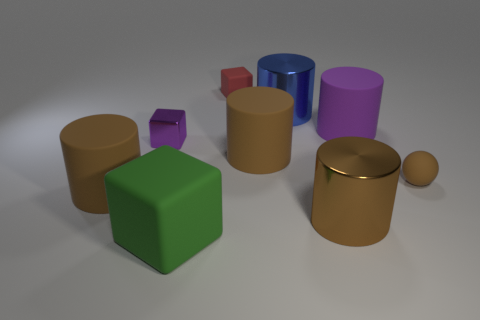Subtract all red spheres. How many brown cylinders are left? 3 Subtract 1 cylinders. How many cylinders are left? 4 Subtract all blue cylinders. How many cylinders are left? 4 Subtract all blue metal cylinders. How many cylinders are left? 4 Add 1 purple rubber cylinders. How many objects exist? 10 Subtract all green cylinders. Subtract all red spheres. How many cylinders are left? 5 Subtract all cubes. How many objects are left? 6 Add 8 large blue objects. How many large blue objects exist? 9 Subtract 0 green balls. How many objects are left? 9 Subtract all big blue blocks. Subtract all big green cubes. How many objects are left? 8 